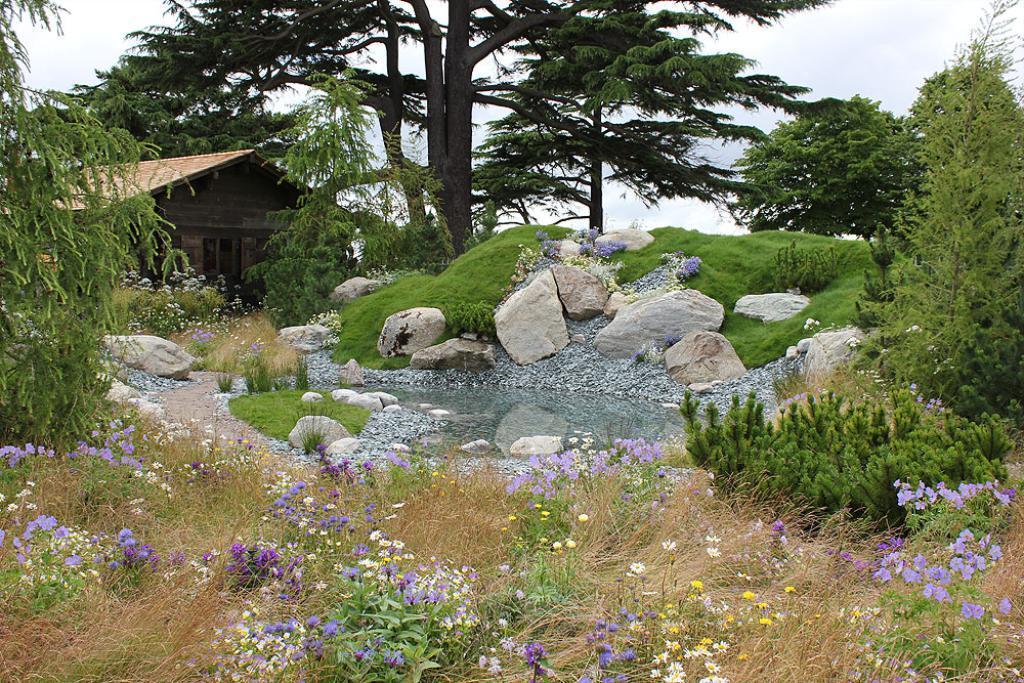Could you give a brief overview of what you see in this image? In this picture we can see some plants and flowers in the front, there are some stones, rocks, water and grass in the middle, in the background there are trees and a house, we can see the sky at the top of the picture. 